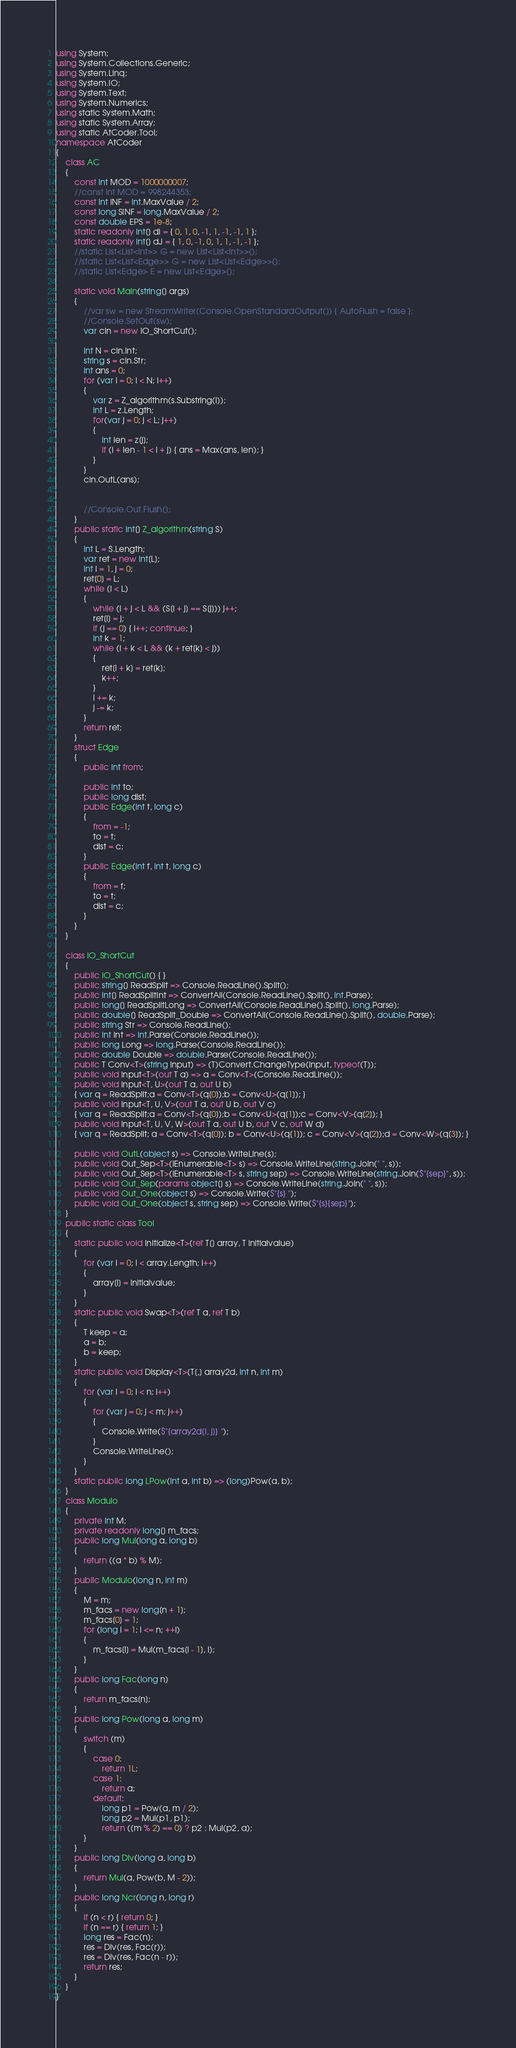<code> <loc_0><loc_0><loc_500><loc_500><_C#_>using System;
using System.Collections.Generic;
using System.Linq;
using System.IO;
using System.Text;
using System.Numerics;
using static System.Math;
using static System.Array;
using static AtCoder.Tool;
namespace AtCoder
{
    class AC
    {
        const int MOD = 1000000007;
        //const int MOD = 998244353;
        const int INF = int.MaxValue / 2;
        const long SINF = long.MaxValue / 2;
        const double EPS = 1e-8;
        static readonly int[] dI = { 0, 1, 0, -1, 1, -1, -1, 1 };
        static readonly int[] dJ = { 1, 0, -1, 0, 1, 1, -1, -1 };
        //static List<List<int>> G = new List<List<int>>();
        //static List<List<Edge>> G = new List<List<Edge>>();
        //static List<Edge> E = new List<Edge>();

        static void Main(string[] args)
        {
            //var sw = new StreamWriter(Console.OpenStandardOutput()) { AutoFlush = false };
            //Console.SetOut(sw);
            var cin = new IO_ShortCut();

            int N = cin.Int;
            string s = cin.Str;
            int ans = 0;
            for (var i = 0; i < N; i++)
            {
                var z = Z_algorithm(s.Substring(i));
                int L = z.Length;
                for(var j = 0; j < L; j++)
                {
                    int len = z[j];
                    if (i + len - 1 < i + j) { ans = Max(ans, len); }
                }
            }
            cin.OutL(ans);

            
            //Console.Out.Flush();
        }
        public static int[] Z_algorithm(string S)
        {
            int L = S.Length;
            var ret = new int[L];
            int i = 1, j = 0;
            ret[0] = L;
            while (i < L)
            {
                while (i + j < L && (S[i + j] == S[j])) j++;
                ret[i] = j;
                if (j == 0) { i++; continue; }
                int k = 1;
                while (i + k < L && (k + ret[k] < j))
                {
                    ret[i + k] = ret[k];
                    k++;
                }
                i += k;
                j -= k;
            }
            return ret;
        }
        struct Edge
        {
            public int from;

            public int to;
            public long dist;
            public Edge(int t, long c)
            {
                from = -1;
                to = t;
                dist = c;
            }
            public Edge(int f, int t, long c)
            {
                from = f;
                to = t;
                dist = c;
            }
        }
    }
    
    class IO_ShortCut
    {
        public IO_ShortCut() { }
        public string[] ReadSplit => Console.ReadLine().Split();
        public int[] ReadSplitInt => ConvertAll(Console.ReadLine().Split(), int.Parse);
        public long[] ReadSplitLong => ConvertAll(Console.ReadLine().Split(), long.Parse);
        public double[] ReadSplit_Double => ConvertAll(Console.ReadLine().Split(), double.Parse);
        public string Str => Console.ReadLine();
        public int Int => int.Parse(Console.ReadLine());
        public long Long => long.Parse(Console.ReadLine());
        public double Double => double.Parse(Console.ReadLine());
        public T Conv<T>(string input) => (T)Convert.ChangeType(input, typeof(T));
        public void Input<T>(out T a) => a = Conv<T>(Console.ReadLine());
        public void Input<T, U>(out T a, out U b)
        { var q = ReadSplit;a = Conv<T>(q[0]);b = Conv<U>(q[1]); }
        public void Input<T, U, V>(out T a, out U b, out V c)
        { var q = ReadSplit;a = Conv<T>(q[0]);b = Conv<U>(q[1]);c = Conv<V>(q[2]); }
        public void Input<T, U, V, W>(out T a, out U b, out V c, out W d)
        { var q = ReadSplit; a = Conv<T>(q[0]); b = Conv<U>(q[1]); c = Conv<V>(q[2]);d = Conv<W>(q[3]); }

        public void OutL(object s) => Console.WriteLine(s);
        public void Out_Sep<T>(IEnumerable<T> s) => Console.WriteLine(string.Join(" ", s));
        public void Out_Sep<T>(IEnumerable<T> s, string sep) => Console.WriteLine(string.Join($"{sep}", s));
        public void Out_Sep(params object[] s) => Console.WriteLine(string.Join(" ", s));
        public void Out_One(object s) => Console.Write($"{s} ");
        public void Out_One(object s, string sep) => Console.Write($"{s}{sep}");
    }
    public static class Tool
    {
        static public void Initialize<T>(ref T[] array, T initialvalue)
        {
            for (var i = 0; i < array.Length; i++)
            {
                array[i] = initialvalue;
            }
        }
        static public void Swap<T>(ref T a, ref T b)
        {
            T keep = a;
            a = b;
            b = keep;
        }
        static public void Display<T>(T[,] array2d, int n, int m)
        {
            for (var i = 0; i < n; i++)
            {
                for (var j = 0; j < m; j++)
                {
                    Console.Write($"{array2d[i, j]} ");
                }
                Console.WriteLine();
            }
        }
        static public long LPow(int a, int b) => (long)Pow(a, b);
    }
    class Modulo
    {
        private int M;
        private readonly long[] m_facs;
        public long Mul(long a, long b)
        {
            return ((a * b) % M);
        }
        public Modulo(long n, int m)
        {
            M = m;
            m_facs = new long[n + 1];
            m_facs[0] = 1;
            for (long i = 1; i <= n; ++i)
            {
                m_facs[i] = Mul(m_facs[i - 1], i);
            }
        }
        public long Fac(long n)
        {
            return m_facs[n];
        }
        public long Pow(long a, long m)
        {
            switch (m)
            {
                case 0:
                    return 1L;
                case 1:
                    return a;
                default:
                    long p1 = Pow(a, m / 2);
                    long p2 = Mul(p1, p1);
                    return ((m % 2) == 0) ? p2 : Mul(p2, a);
            }
        }
        public long Div(long a, long b)
        {
            return Mul(a, Pow(b, M - 2));
        }
        public long Ncr(long n, long r)
        {
            if (n < r) { return 0; }
            if (n == r) { return 1; }
            long res = Fac(n);
            res = Div(res, Fac(r));
            res = Div(res, Fac(n - r));
            return res;
        }
    }
}
</code> 